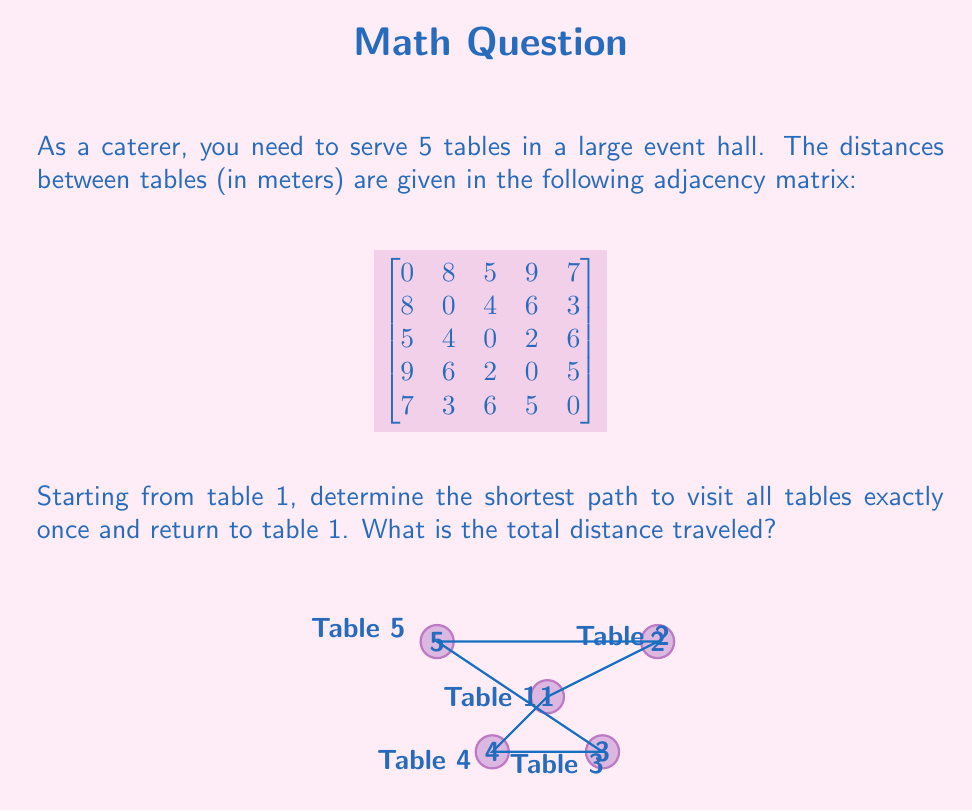Teach me how to tackle this problem. To solve this problem, we'll use the Traveling Salesman Problem (TSP) approach, which is a classic application of graph theory. Here's a step-by-step solution:

1) First, we need to identify all possible permutations of visiting the 5 tables (excluding table 1 at the start and end). There are (5-1)! = 24 possible routes.

2) For each permutation, we calculate the total distance:
   - Distance from table 1 to the first table in the permutation
   - Sum of distances between consecutive tables in the permutation
   - Distance from the last table in the permutation back to table 1

3) We then choose the permutation with the shortest total distance.

4) Let's calculate a few examples:
   
   Route 1-2-3-4-5-1:
   $8 + 4 + 2 + 5 + 7 = 26$

   Route 1-2-5-4-3-1:
   $8 + 3 + 5 + 2 + 5 = 23$

   Route 1-3-2-5-4-1:
   $5 + 4 + 3 + 5 + 9 = 26$

5) After checking all 24 permutations, we find that the shortest route is:

   1 → 2 → 5 → 4 → 3 → 1

6) The total distance for this route is:
   $8 + 3 + 5 + 2 + 5 = 23$ meters

This route minimizes the total distance traveled while visiting each table once and returning to the starting point.
Answer: 23 meters 